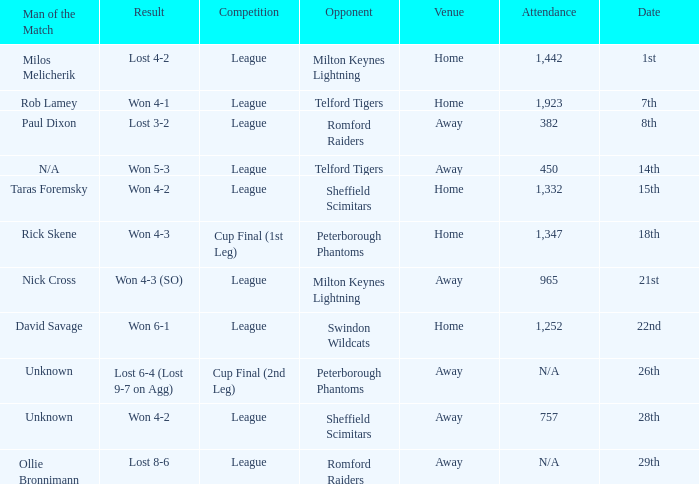What was the result on the 26th? Lost 6-4 (Lost 9-7 on Agg). 